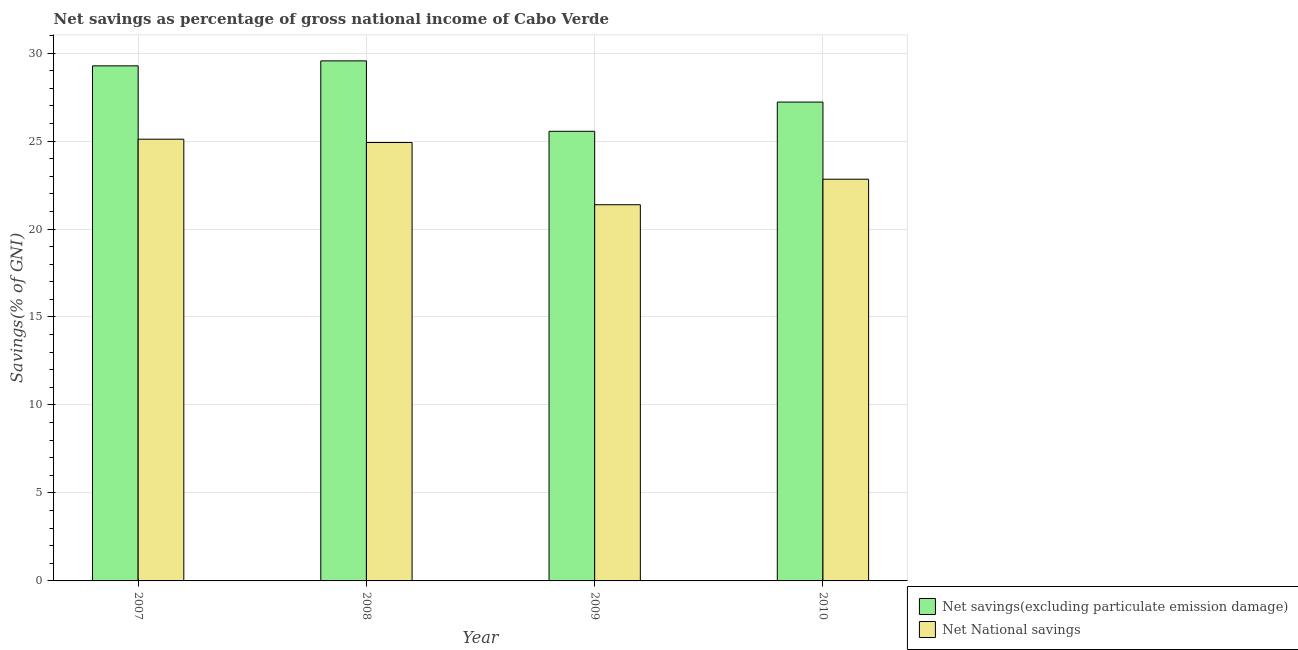How many different coloured bars are there?
Keep it short and to the point. 2. In how many cases, is the number of bars for a given year not equal to the number of legend labels?
Provide a short and direct response. 0. What is the net national savings in 2009?
Your answer should be compact. 21.38. Across all years, what is the maximum net national savings?
Ensure brevity in your answer.  25.1. Across all years, what is the minimum net national savings?
Your answer should be very brief. 21.38. In which year was the net savings(excluding particulate emission damage) maximum?
Your response must be concise. 2008. In which year was the net national savings minimum?
Your answer should be compact. 2009. What is the total net savings(excluding particulate emission damage) in the graph?
Offer a terse response. 111.59. What is the difference between the net national savings in 2008 and that in 2009?
Your answer should be very brief. 3.54. What is the difference between the net savings(excluding particulate emission damage) in 2009 and the net national savings in 2007?
Keep it short and to the point. -3.72. What is the average net savings(excluding particulate emission damage) per year?
Provide a short and direct response. 27.9. In the year 2007, what is the difference between the net savings(excluding particulate emission damage) and net national savings?
Provide a short and direct response. 0. In how many years, is the net savings(excluding particulate emission damage) greater than 26 %?
Your answer should be compact. 3. What is the ratio of the net national savings in 2007 to that in 2008?
Make the answer very short. 1.01. What is the difference between the highest and the second highest net savings(excluding particulate emission damage)?
Provide a succinct answer. 0.28. What is the difference between the highest and the lowest net national savings?
Give a very brief answer. 3.72. What does the 1st bar from the left in 2010 represents?
Your answer should be very brief. Net savings(excluding particulate emission damage). What does the 1st bar from the right in 2008 represents?
Your answer should be very brief. Net National savings. Are the values on the major ticks of Y-axis written in scientific E-notation?
Keep it short and to the point. No. Does the graph contain any zero values?
Give a very brief answer. No. How many legend labels are there?
Give a very brief answer. 2. How are the legend labels stacked?
Your response must be concise. Vertical. What is the title of the graph?
Make the answer very short. Net savings as percentage of gross national income of Cabo Verde. What is the label or title of the Y-axis?
Give a very brief answer. Savings(% of GNI). What is the Savings(% of GNI) in Net savings(excluding particulate emission damage) in 2007?
Provide a short and direct response. 29.27. What is the Savings(% of GNI) in Net National savings in 2007?
Offer a terse response. 25.1. What is the Savings(% of GNI) in Net savings(excluding particulate emission damage) in 2008?
Ensure brevity in your answer.  29.55. What is the Savings(% of GNI) in Net National savings in 2008?
Provide a succinct answer. 24.91. What is the Savings(% of GNI) of Net savings(excluding particulate emission damage) in 2009?
Provide a succinct answer. 25.55. What is the Savings(% of GNI) of Net National savings in 2009?
Your answer should be very brief. 21.38. What is the Savings(% of GNI) in Net savings(excluding particulate emission damage) in 2010?
Provide a succinct answer. 27.21. What is the Savings(% of GNI) in Net National savings in 2010?
Give a very brief answer. 22.83. Across all years, what is the maximum Savings(% of GNI) of Net savings(excluding particulate emission damage)?
Make the answer very short. 29.55. Across all years, what is the maximum Savings(% of GNI) of Net National savings?
Ensure brevity in your answer.  25.1. Across all years, what is the minimum Savings(% of GNI) in Net savings(excluding particulate emission damage)?
Make the answer very short. 25.55. Across all years, what is the minimum Savings(% of GNI) of Net National savings?
Your response must be concise. 21.38. What is the total Savings(% of GNI) in Net savings(excluding particulate emission damage) in the graph?
Ensure brevity in your answer.  111.59. What is the total Savings(% of GNI) of Net National savings in the graph?
Your answer should be very brief. 94.23. What is the difference between the Savings(% of GNI) in Net savings(excluding particulate emission damage) in 2007 and that in 2008?
Your answer should be very brief. -0.28. What is the difference between the Savings(% of GNI) of Net National savings in 2007 and that in 2008?
Your answer should be compact. 0.19. What is the difference between the Savings(% of GNI) of Net savings(excluding particulate emission damage) in 2007 and that in 2009?
Offer a terse response. 3.72. What is the difference between the Savings(% of GNI) in Net National savings in 2007 and that in 2009?
Offer a very short reply. 3.72. What is the difference between the Savings(% of GNI) of Net savings(excluding particulate emission damage) in 2007 and that in 2010?
Ensure brevity in your answer.  2.06. What is the difference between the Savings(% of GNI) of Net National savings in 2007 and that in 2010?
Your response must be concise. 2.27. What is the difference between the Savings(% of GNI) in Net savings(excluding particulate emission damage) in 2008 and that in 2009?
Provide a succinct answer. 4. What is the difference between the Savings(% of GNI) in Net National savings in 2008 and that in 2009?
Offer a very short reply. 3.54. What is the difference between the Savings(% of GNI) in Net savings(excluding particulate emission damage) in 2008 and that in 2010?
Provide a short and direct response. 2.34. What is the difference between the Savings(% of GNI) in Net National savings in 2008 and that in 2010?
Your answer should be compact. 2.08. What is the difference between the Savings(% of GNI) of Net savings(excluding particulate emission damage) in 2009 and that in 2010?
Your answer should be very brief. -1.66. What is the difference between the Savings(% of GNI) in Net National savings in 2009 and that in 2010?
Make the answer very short. -1.45. What is the difference between the Savings(% of GNI) of Net savings(excluding particulate emission damage) in 2007 and the Savings(% of GNI) of Net National savings in 2008?
Your answer should be very brief. 4.36. What is the difference between the Savings(% of GNI) in Net savings(excluding particulate emission damage) in 2007 and the Savings(% of GNI) in Net National savings in 2009?
Offer a terse response. 7.89. What is the difference between the Savings(% of GNI) of Net savings(excluding particulate emission damage) in 2007 and the Savings(% of GNI) of Net National savings in 2010?
Your answer should be compact. 6.44. What is the difference between the Savings(% of GNI) in Net savings(excluding particulate emission damage) in 2008 and the Savings(% of GNI) in Net National savings in 2009?
Provide a succinct answer. 8.18. What is the difference between the Savings(% of GNI) of Net savings(excluding particulate emission damage) in 2008 and the Savings(% of GNI) of Net National savings in 2010?
Offer a terse response. 6.72. What is the difference between the Savings(% of GNI) of Net savings(excluding particulate emission damage) in 2009 and the Savings(% of GNI) of Net National savings in 2010?
Ensure brevity in your answer.  2.72. What is the average Savings(% of GNI) in Net savings(excluding particulate emission damage) per year?
Make the answer very short. 27.9. What is the average Savings(% of GNI) in Net National savings per year?
Your answer should be very brief. 23.56. In the year 2007, what is the difference between the Savings(% of GNI) in Net savings(excluding particulate emission damage) and Savings(% of GNI) in Net National savings?
Your response must be concise. 4.17. In the year 2008, what is the difference between the Savings(% of GNI) in Net savings(excluding particulate emission damage) and Savings(% of GNI) in Net National savings?
Keep it short and to the point. 4.64. In the year 2009, what is the difference between the Savings(% of GNI) in Net savings(excluding particulate emission damage) and Savings(% of GNI) in Net National savings?
Keep it short and to the point. 4.17. In the year 2010, what is the difference between the Savings(% of GNI) of Net savings(excluding particulate emission damage) and Savings(% of GNI) of Net National savings?
Give a very brief answer. 4.38. What is the ratio of the Savings(% of GNI) of Net National savings in 2007 to that in 2008?
Make the answer very short. 1.01. What is the ratio of the Savings(% of GNI) of Net savings(excluding particulate emission damage) in 2007 to that in 2009?
Provide a short and direct response. 1.15. What is the ratio of the Savings(% of GNI) of Net National savings in 2007 to that in 2009?
Make the answer very short. 1.17. What is the ratio of the Savings(% of GNI) in Net savings(excluding particulate emission damage) in 2007 to that in 2010?
Provide a succinct answer. 1.08. What is the ratio of the Savings(% of GNI) of Net National savings in 2007 to that in 2010?
Keep it short and to the point. 1.1. What is the ratio of the Savings(% of GNI) of Net savings(excluding particulate emission damage) in 2008 to that in 2009?
Provide a short and direct response. 1.16. What is the ratio of the Savings(% of GNI) of Net National savings in 2008 to that in 2009?
Give a very brief answer. 1.17. What is the ratio of the Savings(% of GNI) of Net savings(excluding particulate emission damage) in 2008 to that in 2010?
Provide a succinct answer. 1.09. What is the ratio of the Savings(% of GNI) in Net National savings in 2008 to that in 2010?
Make the answer very short. 1.09. What is the ratio of the Savings(% of GNI) of Net savings(excluding particulate emission damage) in 2009 to that in 2010?
Give a very brief answer. 0.94. What is the ratio of the Savings(% of GNI) of Net National savings in 2009 to that in 2010?
Offer a very short reply. 0.94. What is the difference between the highest and the second highest Savings(% of GNI) of Net savings(excluding particulate emission damage)?
Your response must be concise. 0.28. What is the difference between the highest and the second highest Savings(% of GNI) in Net National savings?
Give a very brief answer. 0.19. What is the difference between the highest and the lowest Savings(% of GNI) in Net savings(excluding particulate emission damage)?
Provide a short and direct response. 4. What is the difference between the highest and the lowest Savings(% of GNI) in Net National savings?
Ensure brevity in your answer.  3.72. 